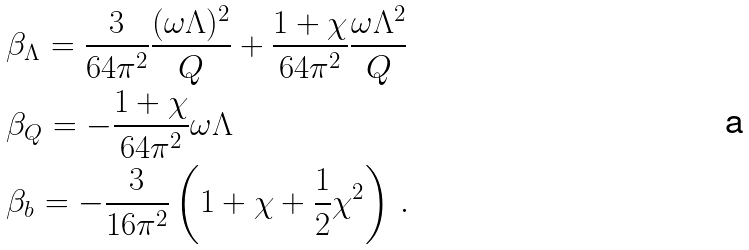<formula> <loc_0><loc_0><loc_500><loc_500>& \beta _ { \Lambda } = \frac { 3 } { 6 4 \pi ^ { 2 } } \frac { ( \omega \Lambda ) ^ { 2 } } { Q } + \frac { 1 + \chi } { 6 4 \pi ^ { 2 } } \frac { \omega \Lambda ^ { 2 } } { Q } \\ & \beta _ { Q } = - \frac { 1 + \chi } { 6 4 \pi ^ { 2 } } \omega \Lambda \\ & \beta _ { b } = - \frac { 3 } { 1 6 \pi ^ { 2 } } \left ( 1 + \chi + \frac { 1 } { 2 } \chi ^ { 2 } \right ) \, .</formula> 